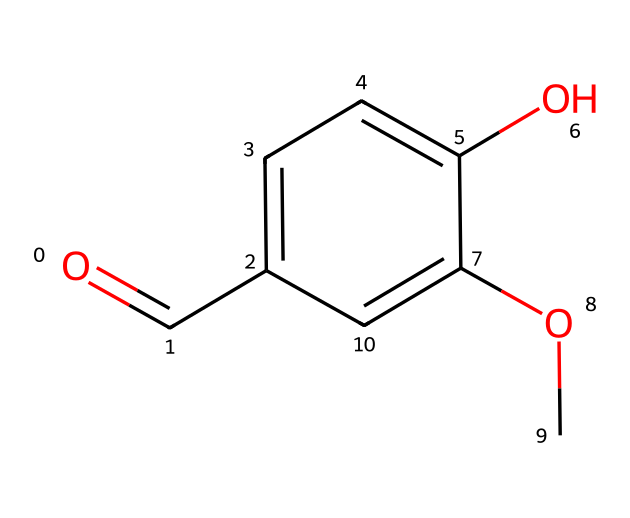What is the molecular formula of vanillin? The SMILES representation indicates the presence of specific atoms: 8 carbon (C), 8 hydrogen (H), and 3 oxygen (O). By combining these counts, the molecular formula can be written as C8H8O3.
Answer: C8H8O3 How many hydroxyl (−OH) groups are present in vanillin? Observing the structure, there is one hydroxyl functional group attached to the aromatic ring, indicated by the presence of the oxygen atom connected to a hydrogen atom.
Answer: 1 What type of functional group is present in vanillin that contributes to its scent? The chemical structure includes a methoxy group (−OCH3) attached to the aromatic ring, which is a type of ether and plays a role in forming the distinctive vanilla scent.
Answer: methoxy group How many double bonds are present in the structure of vanillin? By analyzing the structure, there is one double bond in the carbonyl group (C=O) and another in the aromatic ring between two carbon atoms. Therefore, there are two double bonds in total.
Answer: 2 What is the primary aromatic ring structure in vanillin? The chemical structure clearly shows a phenolic ring, where six carbon atoms form a ring with alternating double bonds, typical of aromatic compounds.
Answer: phenolic ring Is vanillin a polar or non-polar compound? Given the presence of hydroxyl and carbonyl groups, which can form hydrogen bonds, the molecular structure indicates that vanillin is polar.
Answer: polar 